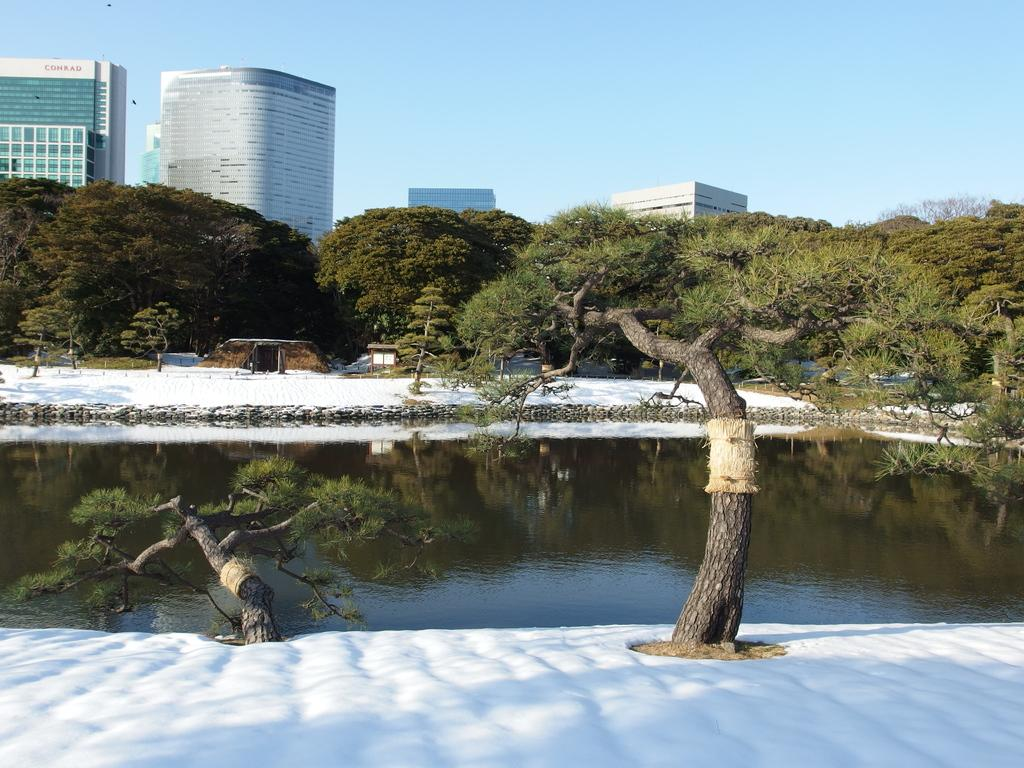How many trees are present in the image? There are two trees in the image. What is the weather like in the image? The presence of snow suggests that it is cold and possibly winter. What can be seen in the background of the image? There is water, buildings, trees, glass doors, windows, and the sky visible in the background. What type of pancake is being served at the sister's birthday party in the image? There is no sister or birthday party present in the image, nor is there any mention of pancakes. 